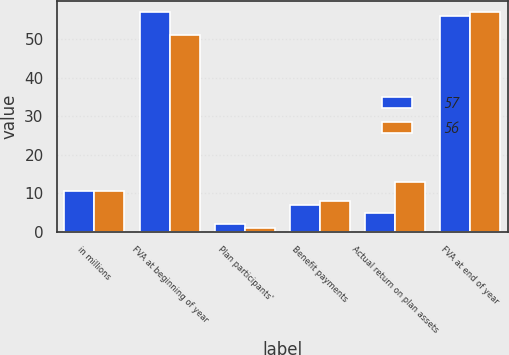Convert chart to OTSL. <chart><loc_0><loc_0><loc_500><loc_500><stacked_bar_chart><ecel><fcel>in millions<fcel>FVA at beginning of year<fcel>Plan participants'<fcel>Benefit payments<fcel>Actual return on plan assets<fcel>FVA at end of year<nl><fcel>57<fcel>10.5<fcel>57<fcel>2<fcel>7<fcel>5<fcel>56<nl><fcel>56<fcel>10.5<fcel>51<fcel>1<fcel>8<fcel>13<fcel>57<nl></chart> 